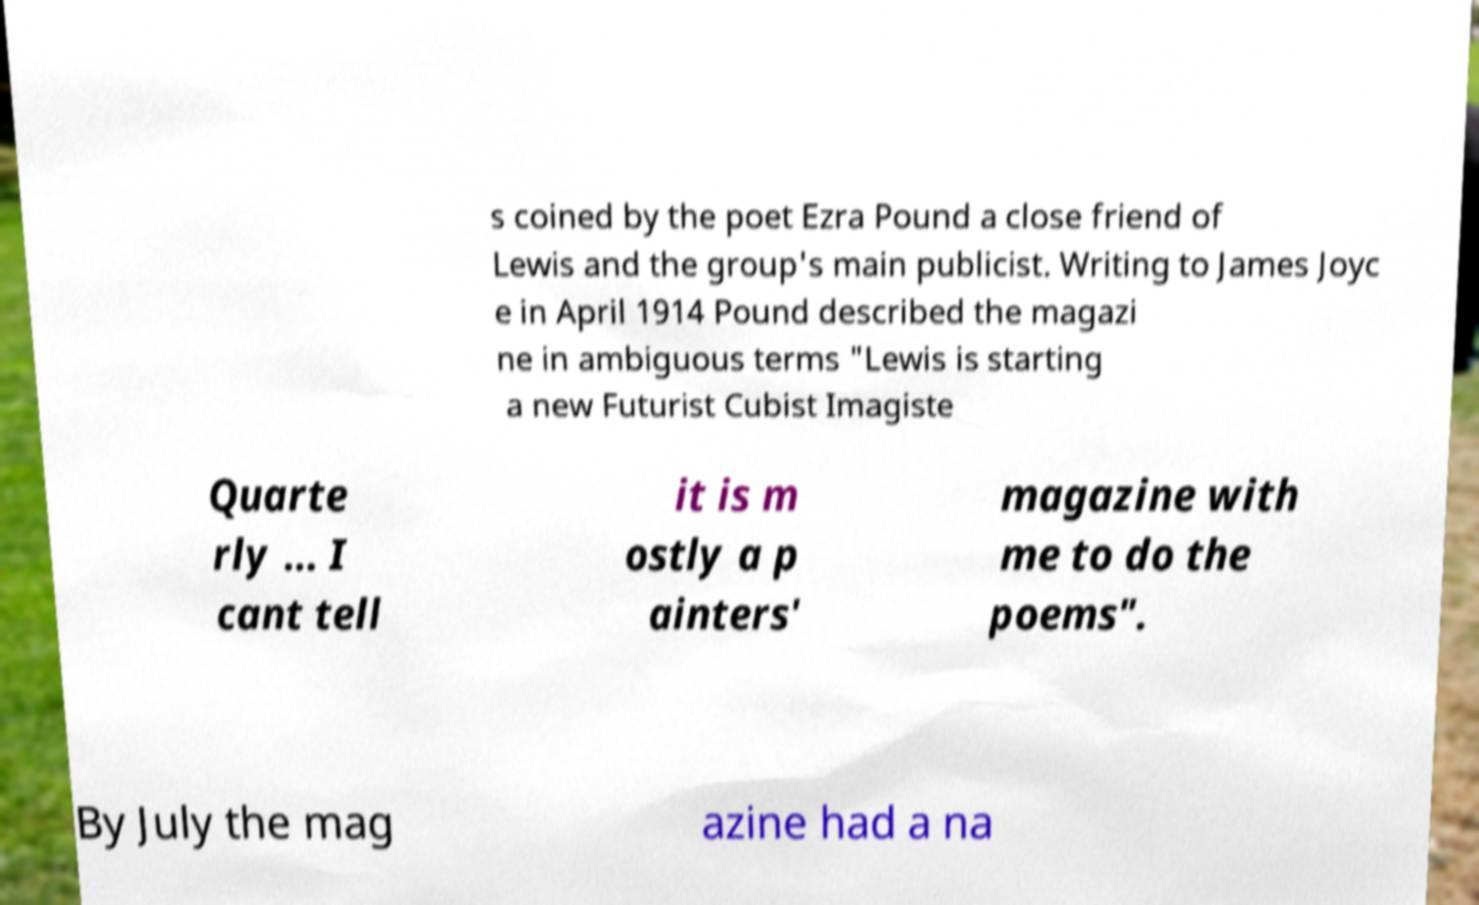Could you assist in decoding the text presented in this image and type it out clearly? s coined by the poet Ezra Pound a close friend of Lewis and the group's main publicist. Writing to James Joyc e in April 1914 Pound described the magazi ne in ambiguous terms "Lewis is starting a new Futurist Cubist Imagiste Quarte rly ... I cant tell it is m ostly a p ainters' magazine with me to do the poems". By July the mag azine had a na 